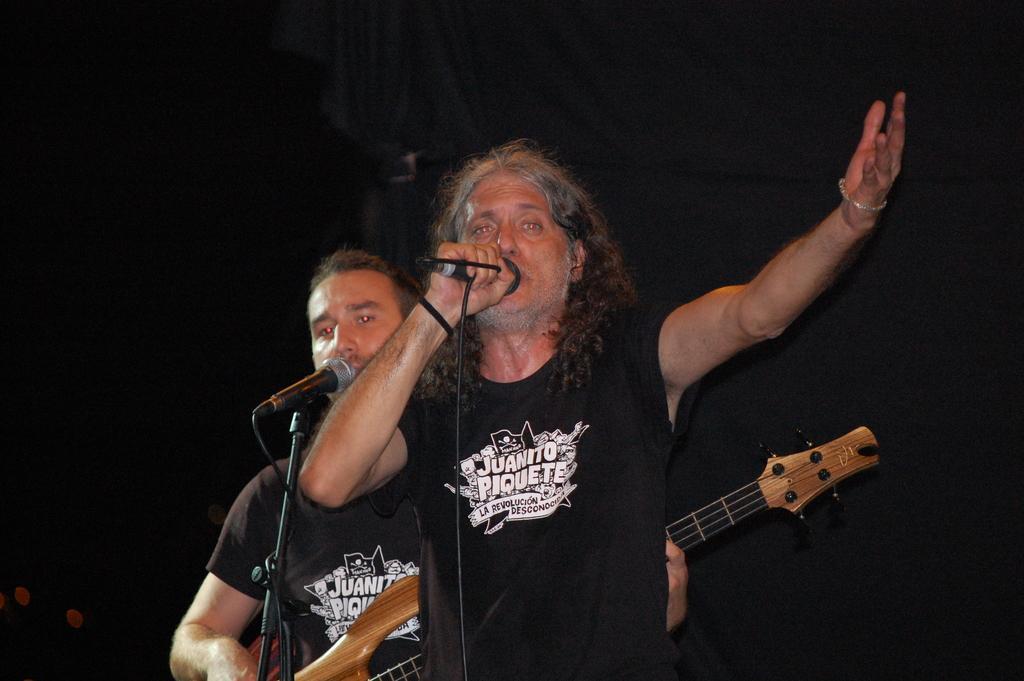How would you summarize this image in a sentence or two? In this picture we can see two men where one is holding guitar in his hand and playing it and both of them are singing on mics and in background it is dark. 